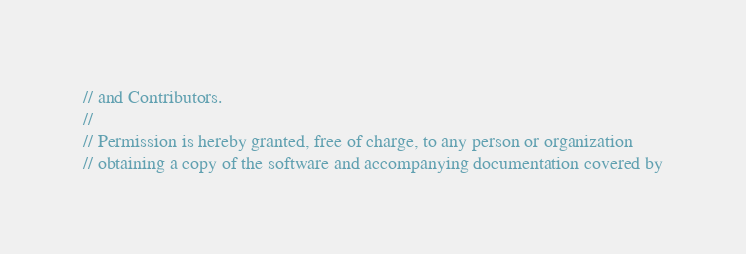Convert code to text. <code><loc_0><loc_0><loc_500><loc_500><_C++_>// and Contributors.
//
// Permission is hereby granted, free of charge, to any person or organization
// obtaining a copy of the software and accompanying documentation covered by</code> 